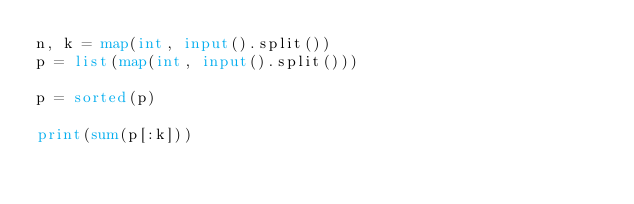<code> <loc_0><loc_0><loc_500><loc_500><_Python_>n, k = map(int, input().split())
p = list(map(int, input().split()))

p = sorted(p)

print(sum(p[:k]))</code> 